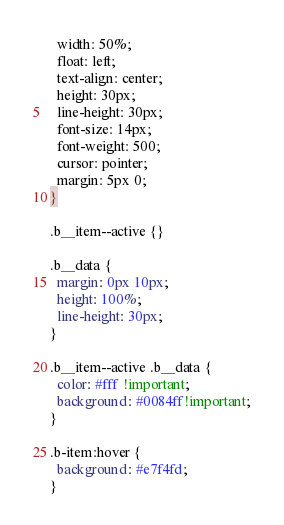Convert code to text. <code><loc_0><loc_0><loc_500><loc_500><_CSS_>  width: 50%;
  float: left;
  text-align: center;
  height: 30px;
  line-height: 30px;
  font-size: 14px;
  font-weight: 500;
  cursor: pointer;
  margin: 5px 0;
}

.b__item--active {}

.b__data {
  margin: 0px 10px;
  height: 100%;
  line-height: 30px;
}

.b__item--active .b__data {
  color: #fff !important;
  background: #0084ff!important;
}

.b-item:hover {
  background: #e7f4fd;
}</code> 